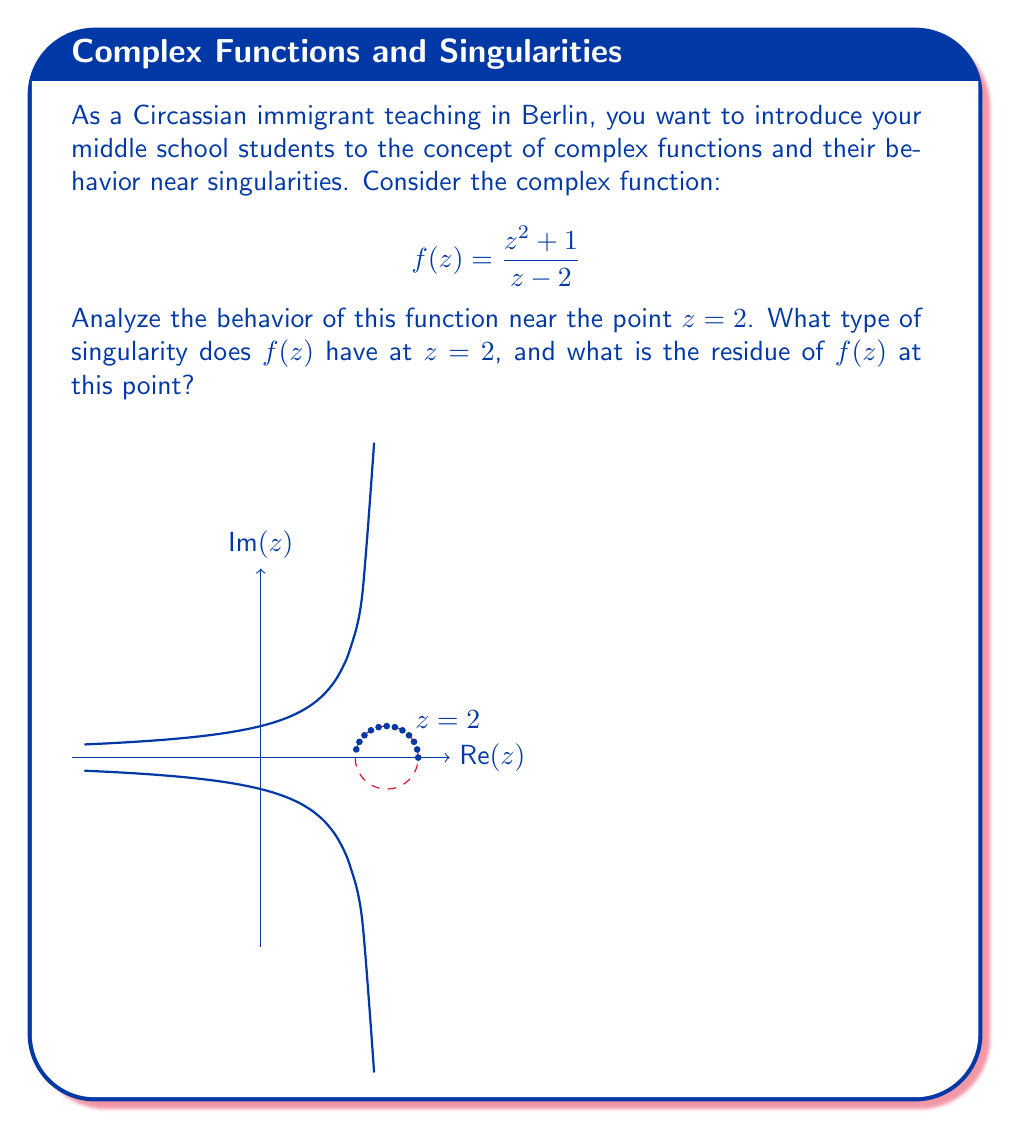Teach me how to tackle this problem. Let's approach this step-by-step:

1) First, we need to determine the type of singularity at $z = 2$. To do this, let's examine the behavior of $f(z)$ as $z$ approaches 2.

2) We can rewrite $f(z)$ as:

   $$f(z) = \frac{z^2 + 1}{z - 2} = \frac{(z-2+2)^2 + 1}{z - 2} = \frac{(z-2)^2 + 4(z-2) + 5}{z - 2}$$

3) Simplifying further:

   $$f(z) = (z-2) + 4 + \frac{5}{z-2}$$

4) As $z$ approaches 2, the term $\frac{5}{z-2}$ becomes unbounded, while the other terms remain finite. This behavior indicates that $z = 2$ is a pole of order 1 (simple pole) for $f(z)$.

5) To find the residue at $z = 2$, we can use the formula for the residue at a simple pole:

   $$\text{Res}(f, 2) = \lim_{z \to 2} (z-2)f(z)$$

6) Substituting our function:

   $$\text{Res}(f, 2) = \lim_{z \to 2} (z-2)\left((z-2) + 4 + \frac{5}{z-2}\right)$$

7) Simplifying:

   $$\text{Res}(f, 2) = \lim_{z \to 2} ((z-2)^2 + 4(z-2) + 5) = 5$$

Therefore, $f(z)$ has a simple pole at $z = 2$, and the residue at this point is 5.
Answer: Simple pole; Residue = 5 